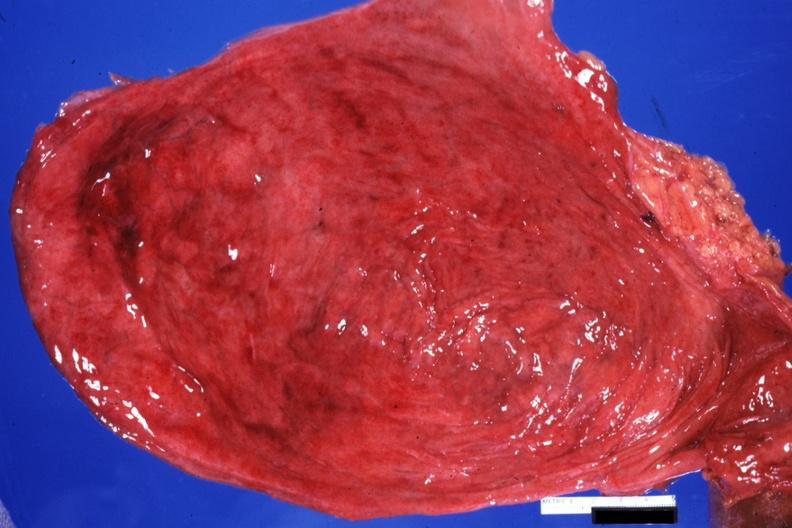does this image show opened bladder quite good with diverticula?
Answer the question using a single word or phrase. Yes 